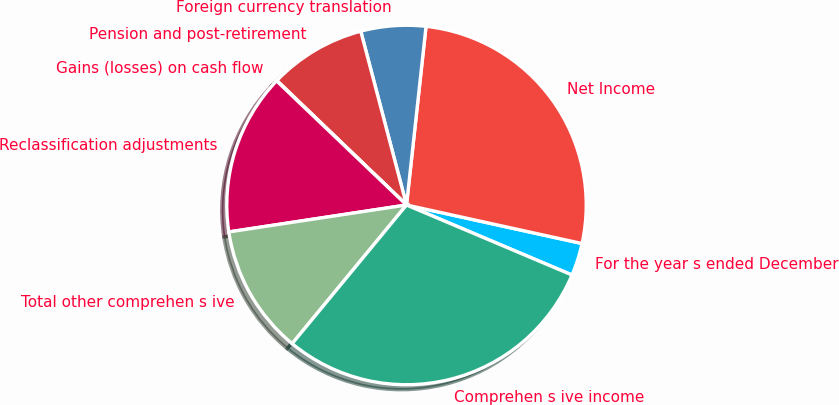<chart> <loc_0><loc_0><loc_500><loc_500><pie_chart><fcel>For the year s ended December<fcel>Net Income<fcel>Foreign currency translation<fcel>Pension and post-retirement<fcel>Gains (losses) on cash flow<fcel>Reclassification adjustments<fcel>Total other comprehen s ive<fcel>Comprehen s ive income<nl><fcel>2.93%<fcel>26.71%<fcel>5.83%<fcel>8.73%<fcel>0.04%<fcel>14.53%<fcel>11.63%<fcel>29.61%<nl></chart> 